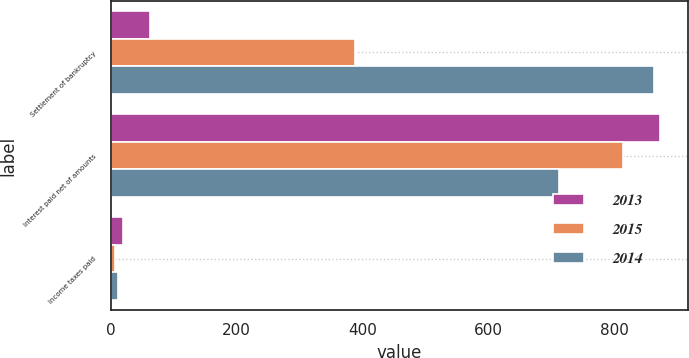Convert chart. <chart><loc_0><loc_0><loc_500><loc_500><stacked_bar_chart><ecel><fcel>Settlement of bankruptcy<fcel>Interest paid net of amounts<fcel>Income taxes paid<nl><fcel>2013<fcel>63<fcel>873<fcel>20<nl><fcel>2015<fcel>388<fcel>814<fcel>7<nl><fcel>2014<fcel>864<fcel>713<fcel>12<nl></chart> 